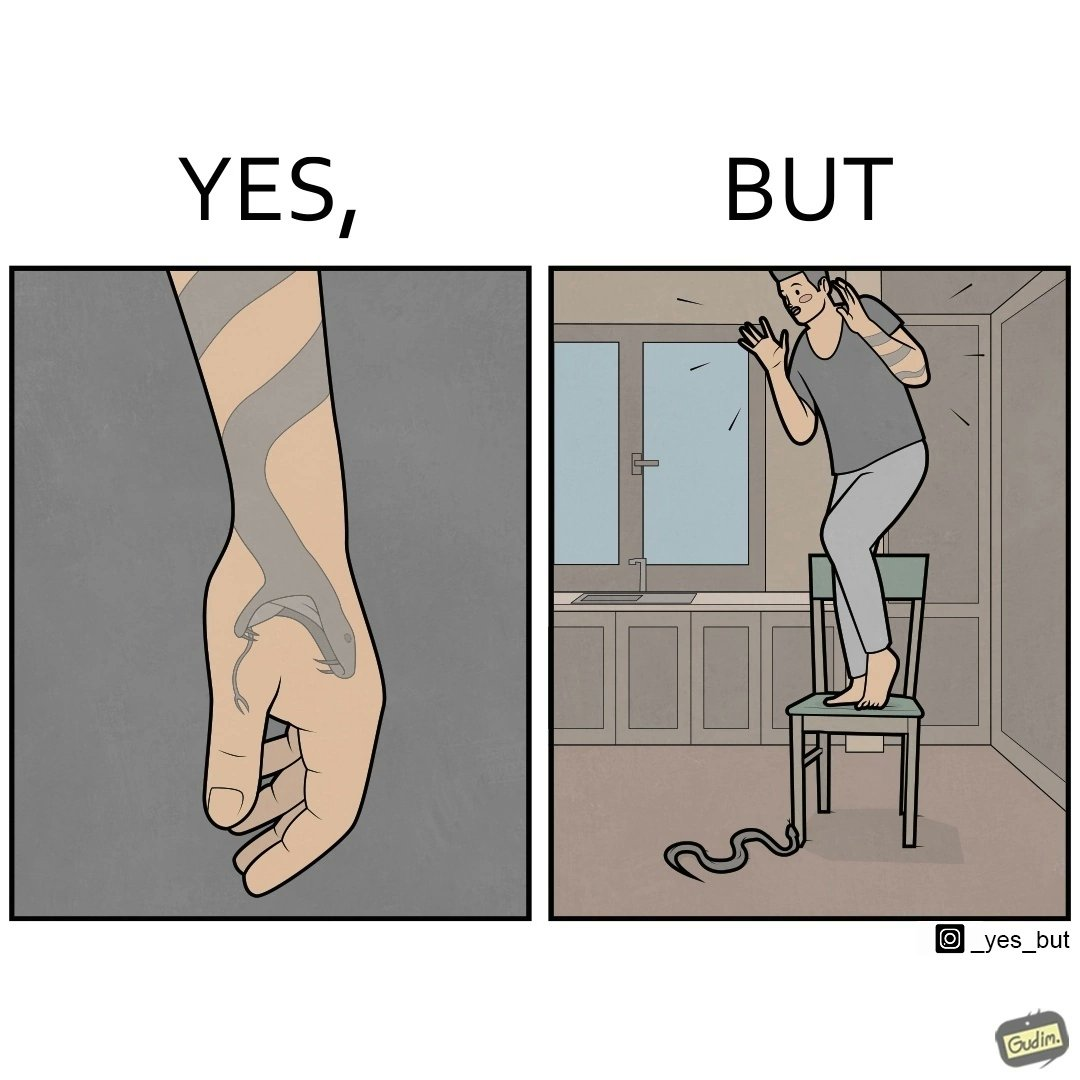Describe the contrast between the left and right parts of this image. In the left part of the image: a tattoo of a snake with its mouth wide open on someone's hand In the right part of the image: a person standing on a chair trying save himself from the attack of snake and the snake is probably trying to climb up the chair 